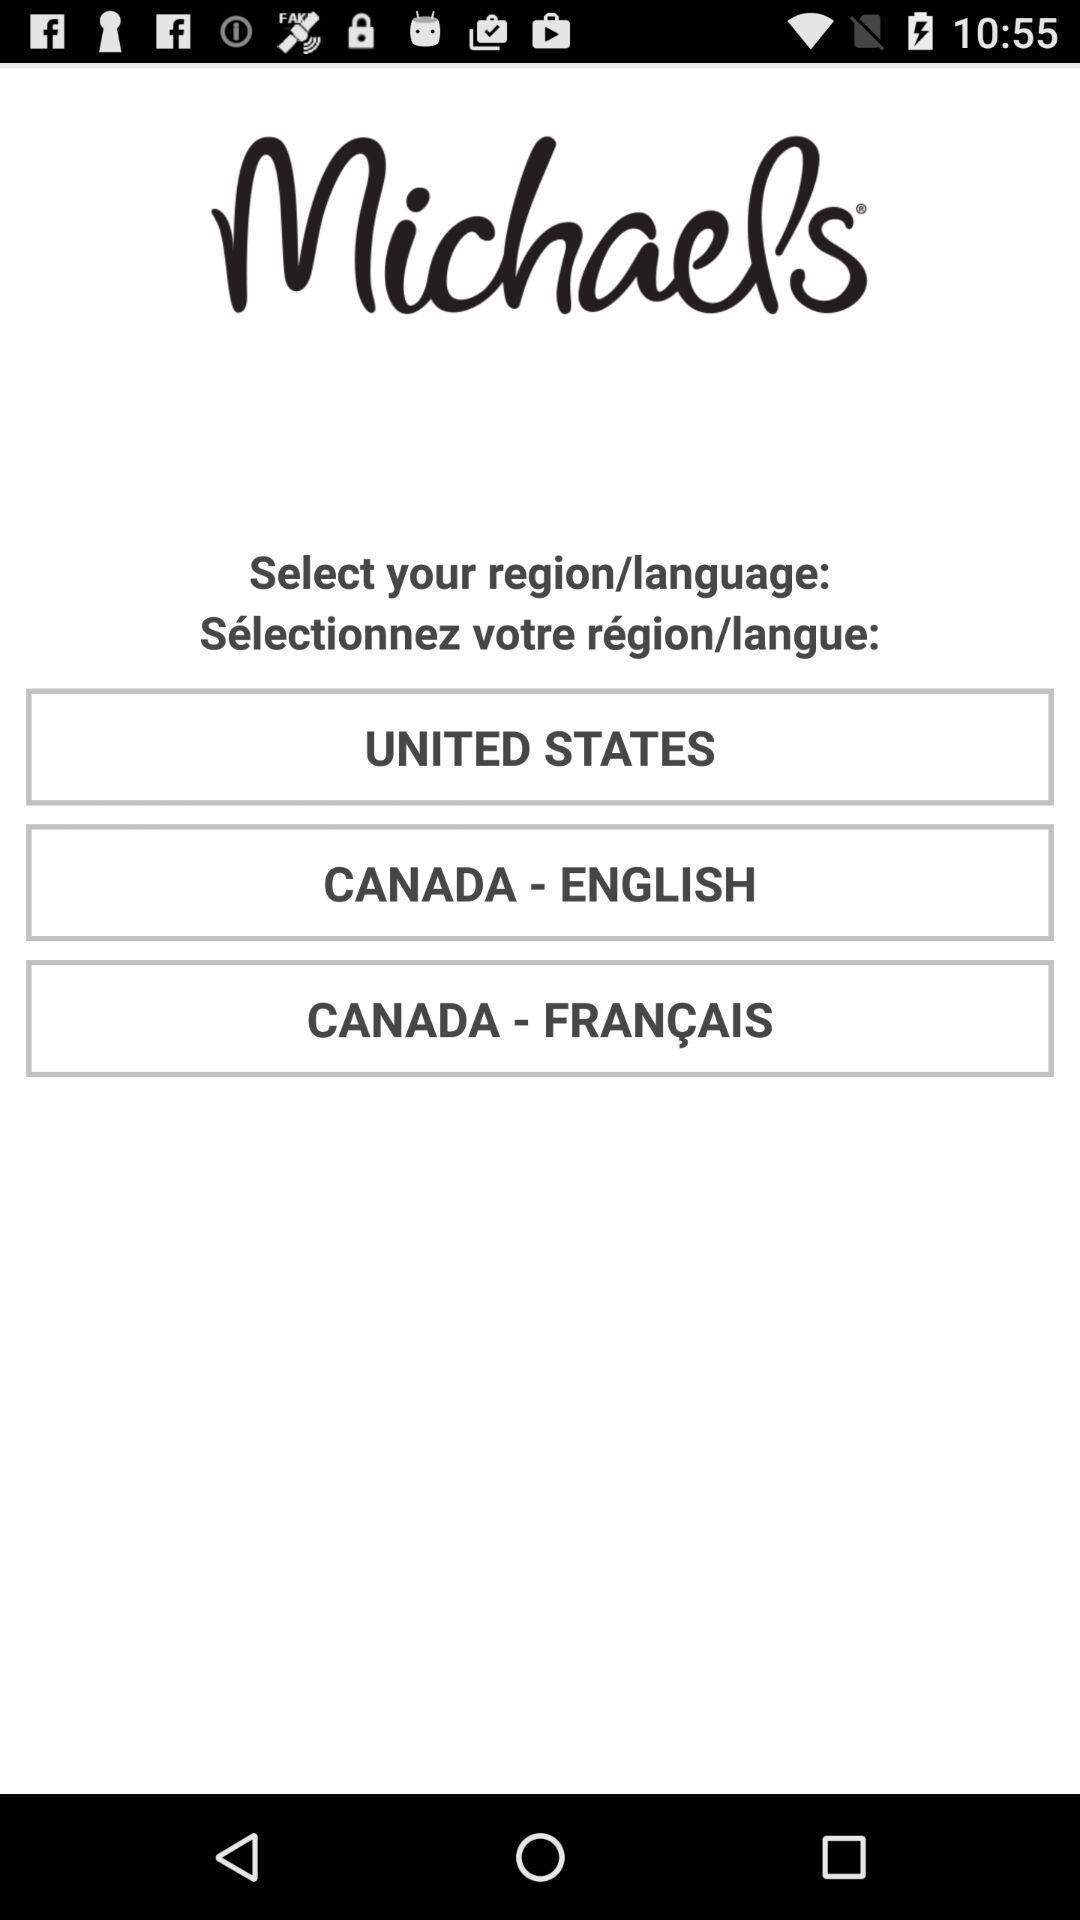Tell me what you see in this picture. Welcome page displayed to select language. 